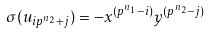Convert formula to latex. <formula><loc_0><loc_0><loc_500><loc_500>\sigma ( u _ { i p ^ { n _ { 2 } } + j } ) = - x ^ { ( p ^ { n _ { 1 } } - i ) } y ^ { ( p ^ { n _ { 2 } } - j ) }</formula> 